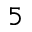<formula> <loc_0><loc_0><loc_500><loc_500>5</formula> 